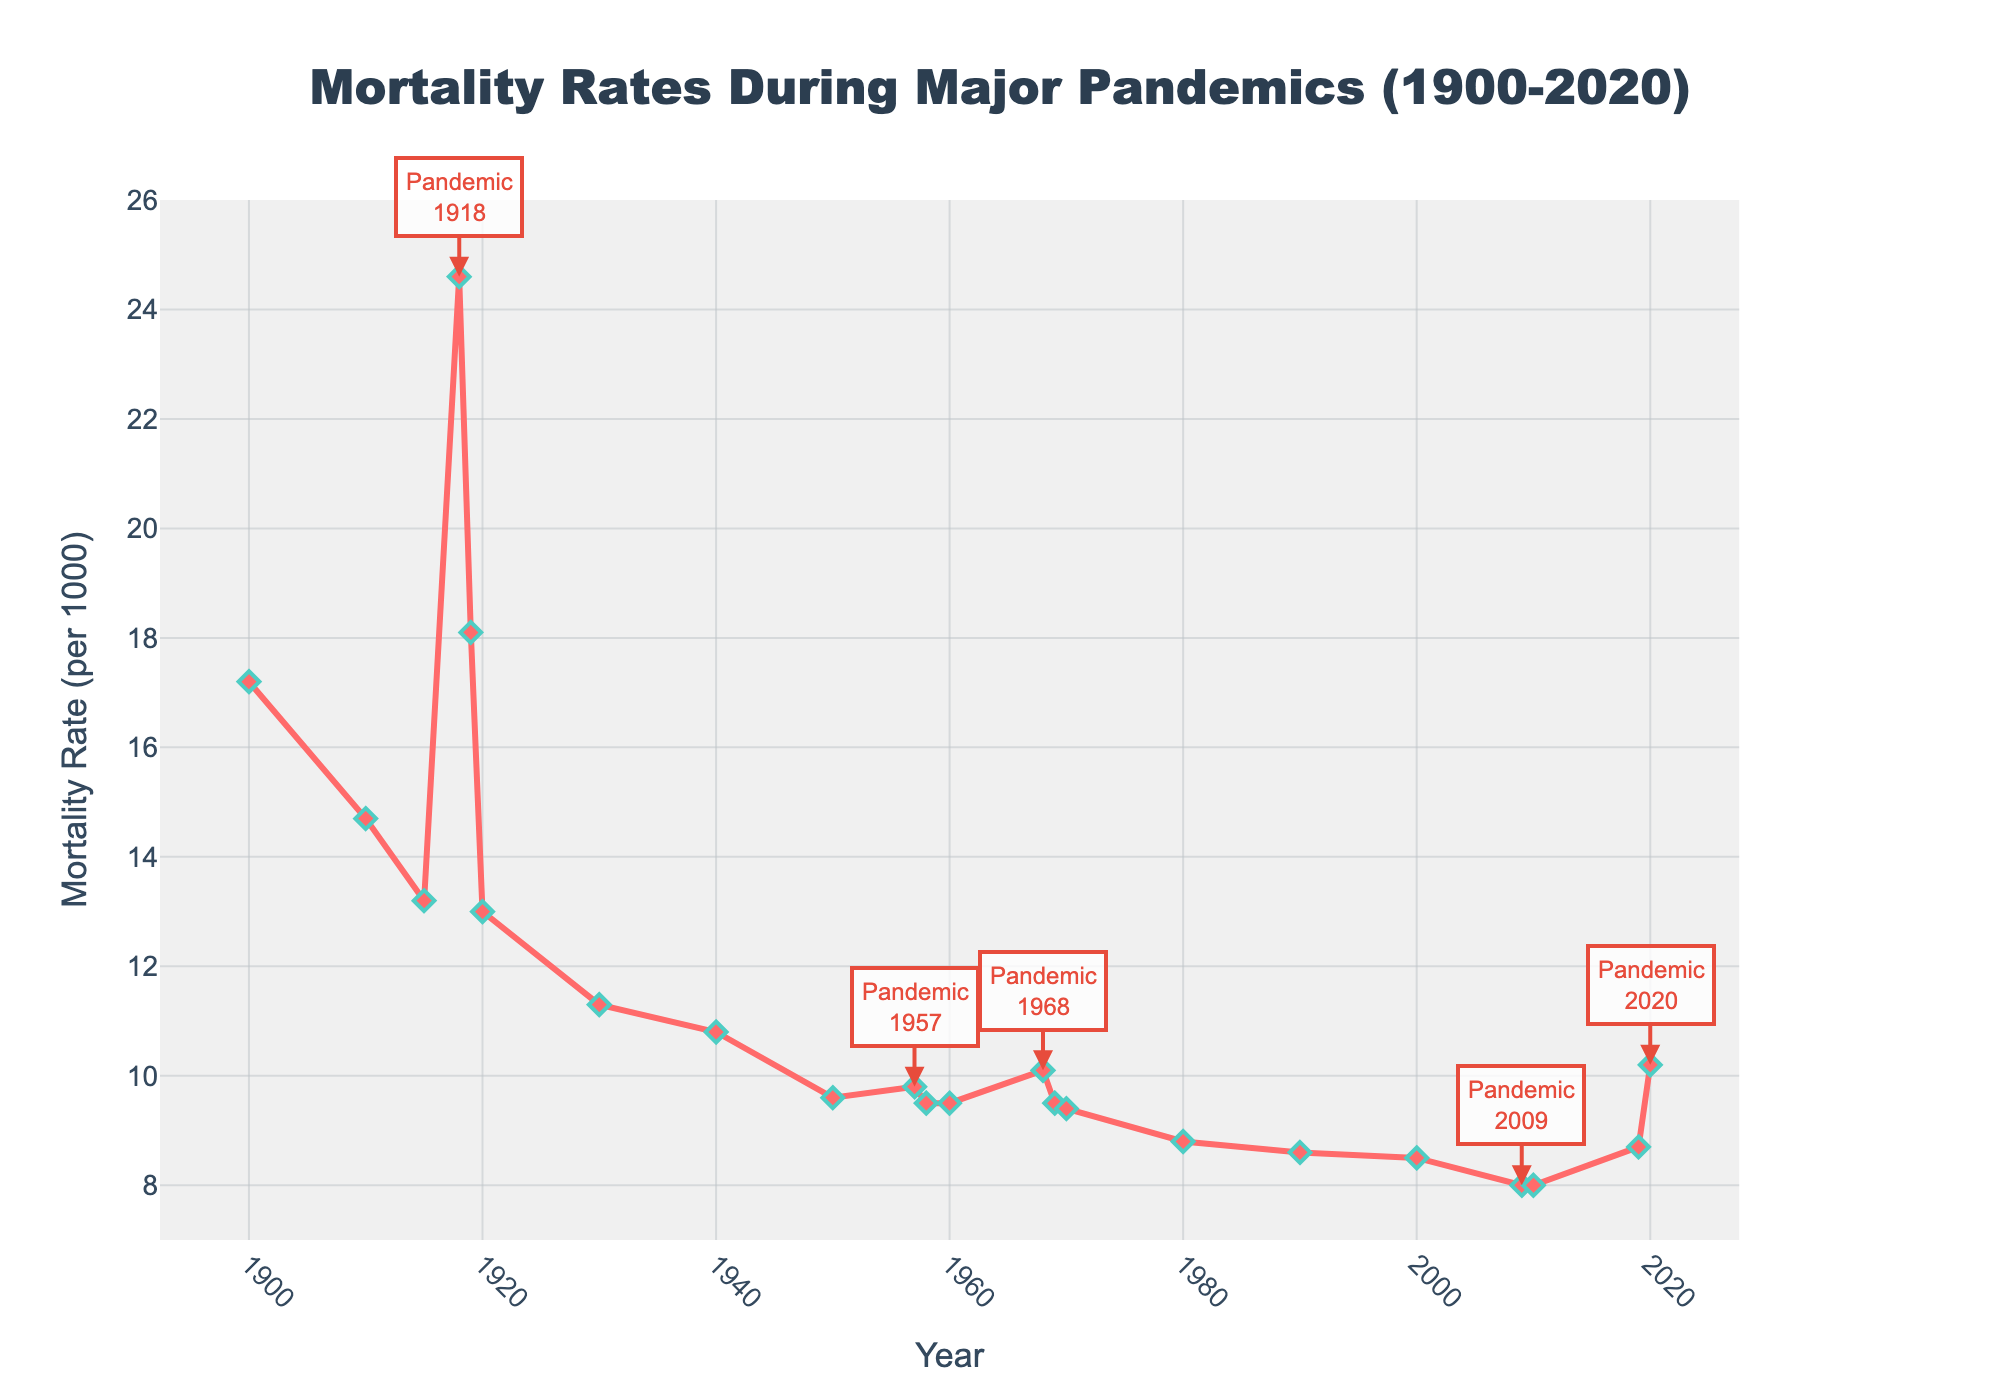What year had the highest mortality rate? Identify the peak in the line plot. The highest mortality rate occurs during the 1918 pandemic, marked with an annotation.
Answer: 1918 Compare the mortality rate in 1918 with that in 1957. Which year had a higher rate? Locate the points for 1918 and 1957 on the chart and compare their mortality rates. 1918's rate is 24.6, while 1957's rate is 9.8.
Answer: 1918 What is the difference in mortality rate between 1918 and 2010? Find the points for 1918 and 2010. The mortality rate in 1918 is 24.6, and in 2010 it is 8.0. The difference is 24.6 - 8.0.
Answer: 16.6 What trend do you observe in the mortality rate from 1900 to 2020? Visually examine the overall trajectory of the line from 1900 to 2020. The trend shows a general decline in mortality rates, with spikes during pandemic years.
Answer: Decline with spikes How much did the mortality rate change from 2019 to 2020? Identify the mortality rates for 2019 and 2020. The rate in 2019 is 8.7, and it is 10.2 in 2020. The change is 10.2 - 8.7.
Answer: 1.5 What major pandemic years are annotated in the chart and how do their mortality rates compare? Look for the annotations and corresponding years marked as pandemic years (1918, 1957, 1968, 2009, 2020). Compare their rates: 24.6, 9.8, 10.1, 8.0, 10.2 respectively.
Answer: 1918 > 1968 > 2020 > 1957 > 2009 Which decade saw the lowest average mortality rate? Calculate the average rate for each decade. For the 2010s (2010 and 2019), the rates are (8.0 + 8.7)/2 = 8.35. Compare all decades' averages; the 2010s have the lowest.
Answer: 2010s Was the mortality rate more stable (less variable) before or after 1950? Compare the variability, or fluctuations, of the line plot before and after 1950. Notice smaller fluctuations after 1950 compared to larger swings before.
Answer: After 1950 What is the mortality rate range for the entire period from 1900 to 2020? Identify the minimum and maximum mortality rates. The minimum is 8.0 (2009, 2010) and the maximum is 24.6 (1918). The range is 24.6 - 8.0.
Answer: 16.6 By how much did the mortality rate decrease from 1900 to 1950? Find the rates for 1900 and 1950. The rate in 1900 is 17.2, and in 1950 it is 9.6. The decrease is 17.2 - 9.6.
Answer: 7.6 